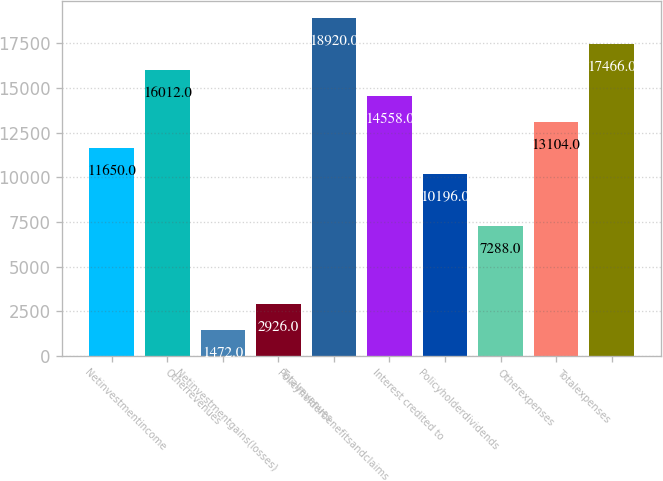<chart> <loc_0><loc_0><loc_500><loc_500><bar_chart><ecel><fcel>Netinvestmentincome<fcel>Otherrevenues<fcel>Netinvestmentgains(losses)<fcel>Totalrevenues<fcel>Policyholderbenefitsandclaims<fcel>Interest credited to<fcel>Policyholderdividends<fcel>Otherexpenses<fcel>Totalexpenses<nl><fcel>11650<fcel>16012<fcel>1472<fcel>2926<fcel>18920<fcel>14558<fcel>10196<fcel>7288<fcel>13104<fcel>17466<nl></chart> 